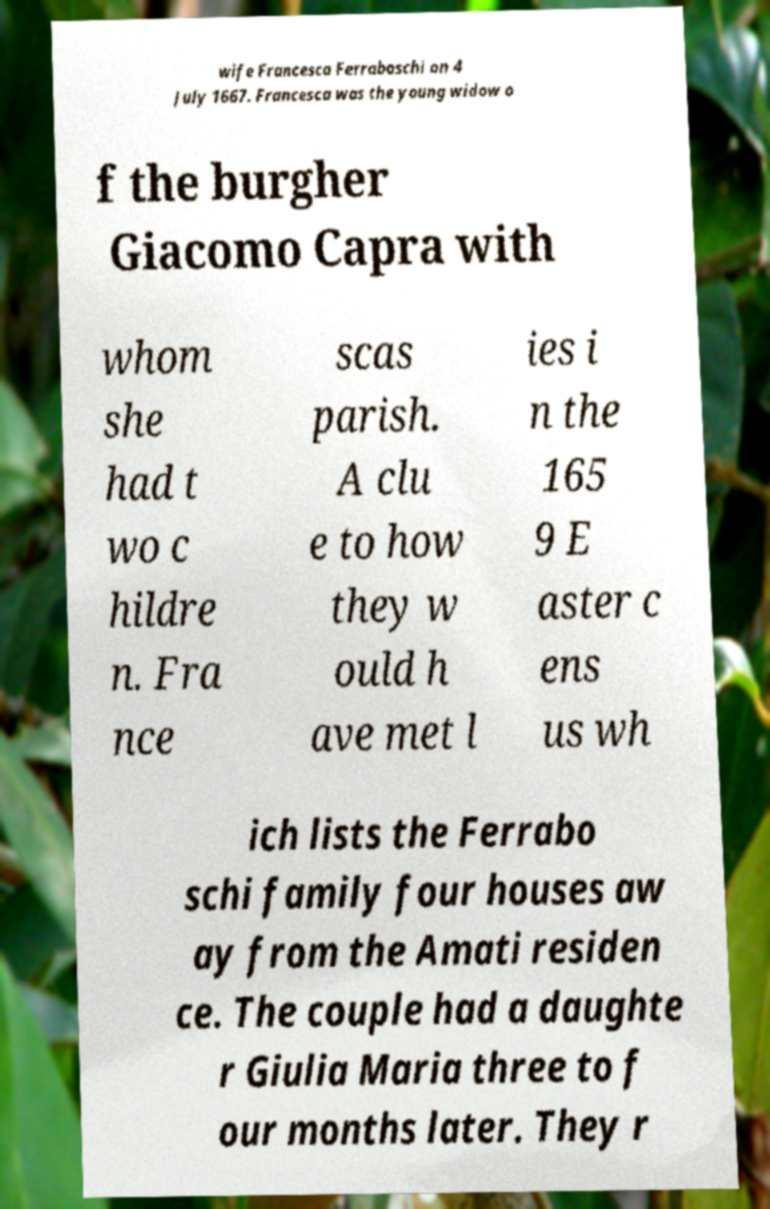There's text embedded in this image that I need extracted. Can you transcribe it verbatim? wife Francesca Ferraboschi on 4 July 1667. Francesca was the young widow o f the burgher Giacomo Capra with whom she had t wo c hildre n. Fra nce scas parish. A clu e to how they w ould h ave met l ies i n the 165 9 E aster c ens us wh ich lists the Ferrabo schi family four houses aw ay from the Amati residen ce. The couple had a daughte r Giulia Maria three to f our months later. They r 